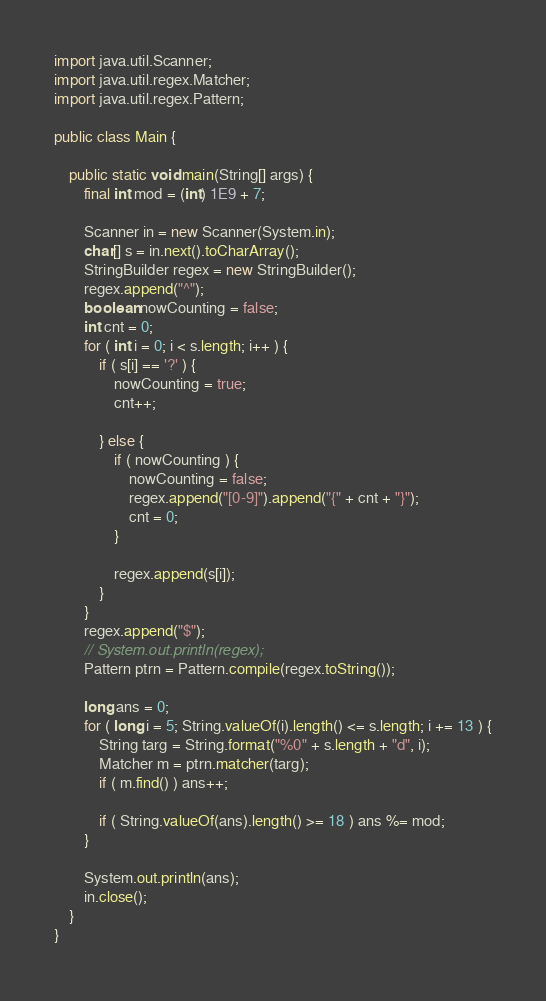<code> <loc_0><loc_0><loc_500><loc_500><_Java_>import java.util.Scanner;
import java.util.regex.Matcher;
import java.util.regex.Pattern;

public class Main {

	public static void main(String[] args) {
		final int mod = (int) 1E9 + 7;

		Scanner in = new Scanner(System.in);
		char[] s = in.next().toCharArray();
		StringBuilder regex = new StringBuilder();
		regex.append("^");
		boolean nowCounting = false;
		int cnt = 0;
		for ( int i = 0; i < s.length; i++ ) {
			if ( s[i] == '?' ) {
				nowCounting = true;
				cnt++;

			} else {
				if ( nowCounting ) {
					nowCounting = false;
					regex.append("[0-9]").append("{" + cnt + "}");
					cnt = 0;
				}

				regex.append(s[i]);
			}
		}
		regex.append("$");
		// System.out.println(regex);
		Pattern ptrn = Pattern.compile(regex.toString());

		long ans = 0;
		for ( long i = 5; String.valueOf(i).length() <= s.length; i += 13 ) {
			String targ = String.format("%0" + s.length + "d", i);
			Matcher m = ptrn.matcher(targ);
			if ( m.find() ) ans++;

			if ( String.valueOf(ans).length() >= 18 ) ans %= mod;
		}

		System.out.println(ans);
		in.close();
	}
}
</code> 